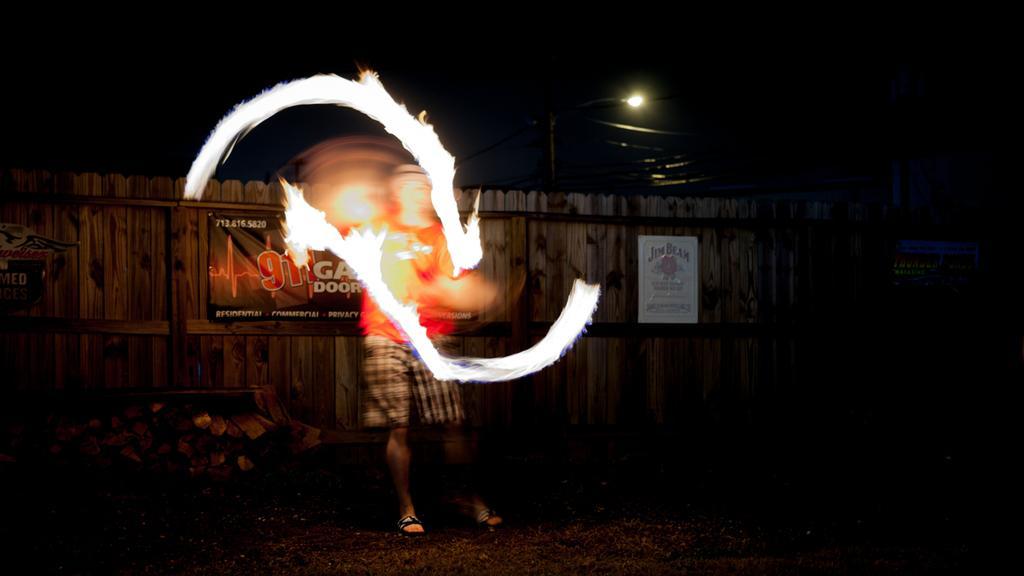How would you summarize this image in a sentence or two? It is an edited image, where we can see a person, posters and a lamp. 